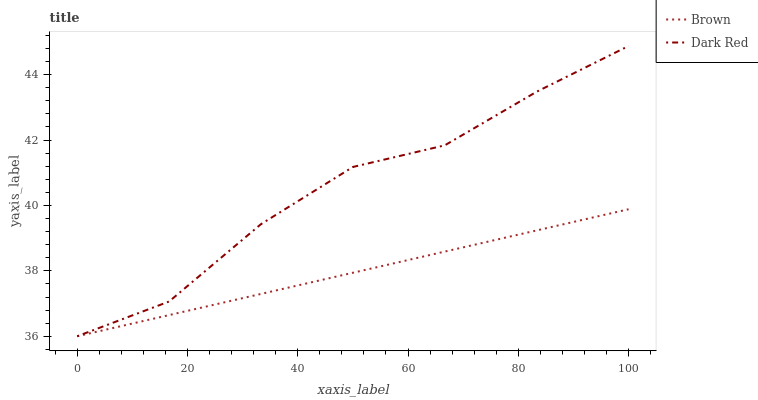Does Brown have the minimum area under the curve?
Answer yes or no. Yes. Does Dark Red have the maximum area under the curve?
Answer yes or no. Yes. Does Dark Red have the minimum area under the curve?
Answer yes or no. No. Is Brown the smoothest?
Answer yes or no. Yes. Is Dark Red the roughest?
Answer yes or no. Yes. Is Dark Red the smoothest?
Answer yes or no. No. Does Brown have the lowest value?
Answer yes or no. Yes. Does Dark Red have the highest value?
Answer yes or no. Yes. Does Dark Red intersect Brown?
Answer yes or no. Yes. Is Dark Red less than Brown?
Answer yes or no. No. Is Dark Red greater than Brown?
Answer yes or no. No. 